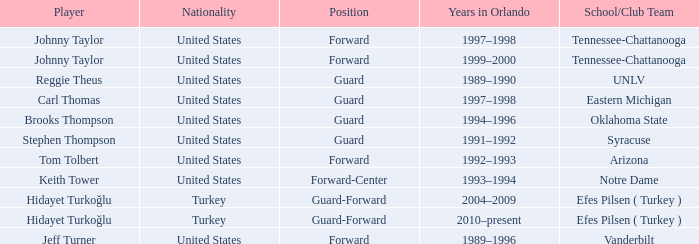What is Stephen Thompson's School/Club Team? Syracuse. 